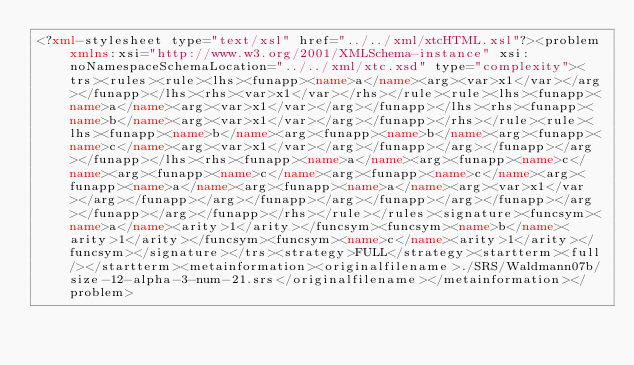<code> <loc_0><loc_0><loc_500><loc_500><_XML_><?xml-stylesheet type="text/xsl" href="../../xml/xtcHTML.xsl"?><problem xmlns:xsi="http://www.w3.org/2001/XMLSchema-instance" xsi:noNamespaceSchemaLocation="../../xml/xtc.xsd" type="complexity"><trs><rules><rule><lhs><funapp><name>a</name><arg><var>x1</var></arg></funapp></lhs><rhs><var>x1</var></rhs></rule><rule><lhs><funapp><name>a</name><arg><var>x1</var></arg></funapp></lhs><rhs><funapp><name>b</name><arg><var>x1</var></arg></funapp></rhs></rule><rule><lhs><funapp><name>b</name><arg><funapp><name>b</name><arg><funapp><name>c</name><arg><var>x1</var></arg></funapp></arg></funapp></arg></funapp></lhs><rhs><funapp><name>a</name><arg><funapp><name>c</name><arg><funapp><name>c</name><arg><funapp><name>c</name><arg><funapp><name>a</name><arg><funapp><name>a</name><arg><var>x1</var></arg></funapp></arg></funapp></arg></funapp></arg></funapp></arg></funapp></arg></funapp></rhs></rule></rules><signature><funcsym><name>a</name><arity>1</arity></funcsym><funcsym><name>b</name><arity>1</arity></funcsym><funcsym><name>c</name><arity>1</arity></funcsym></signature></trs><strategy>FULL</strategy><startterm><full/></startterm><metainformation><originalfilename>./SRS/Waldmann07b/size-12-alpha-3-num-21.srs</originalfilename></metainformation></problem></code> 